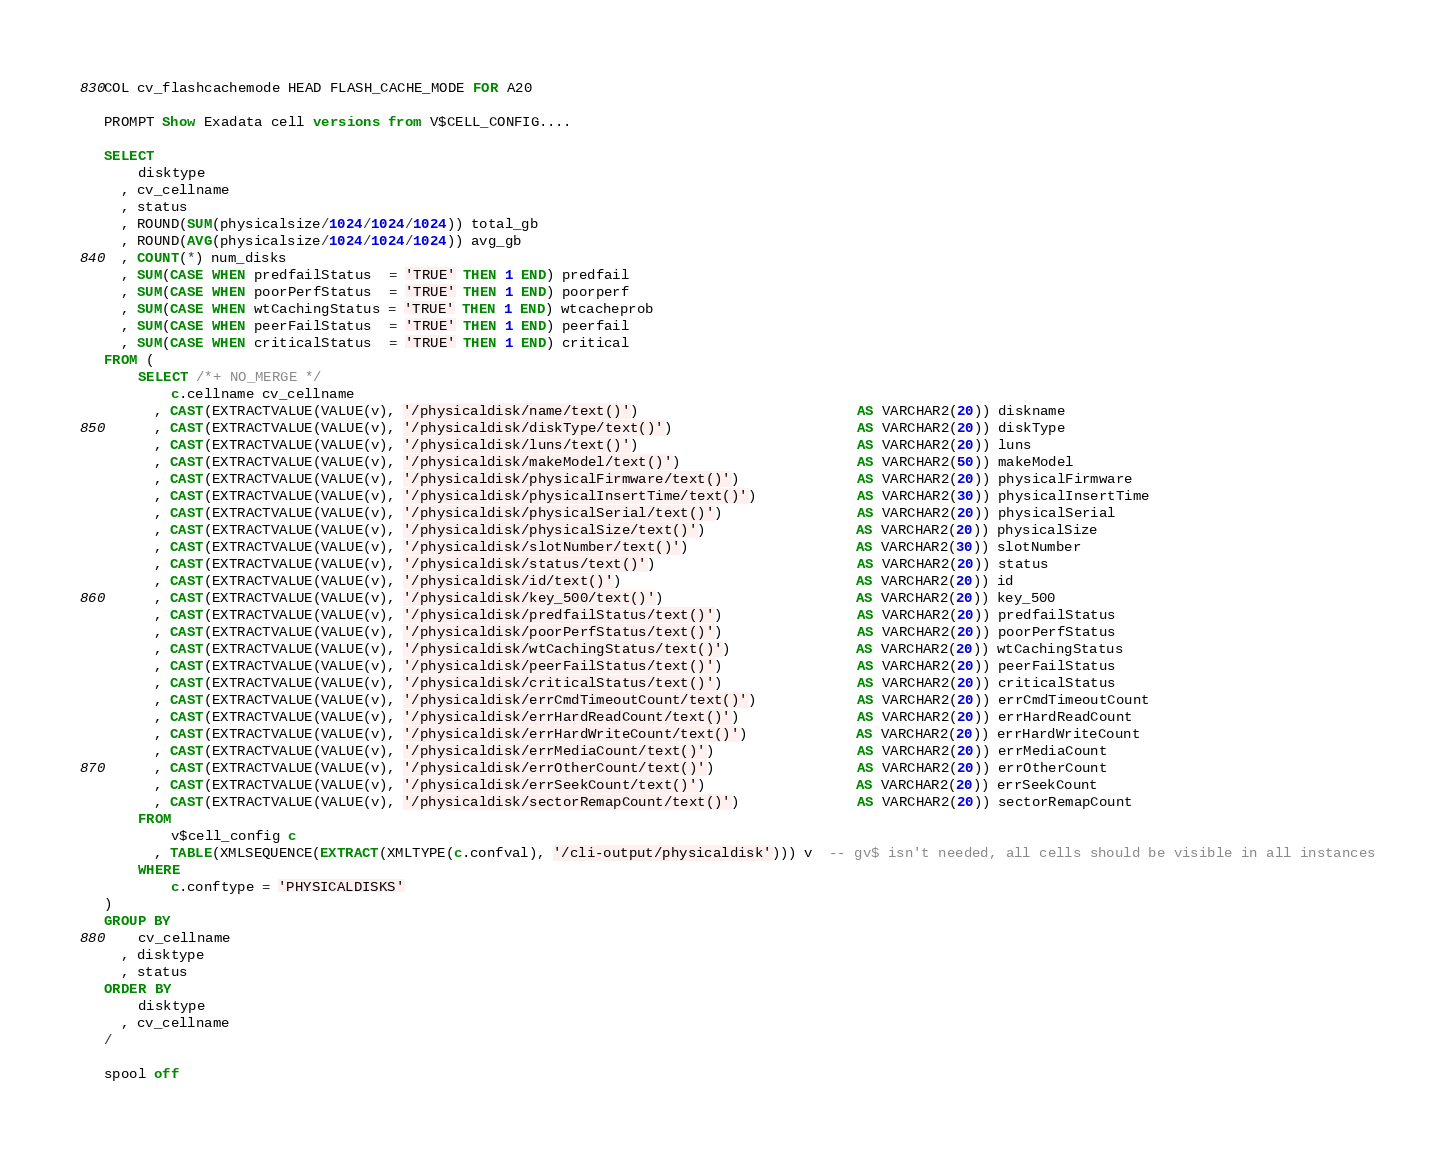<code> <loc_0><loc_0><loc_500><loc_500><_SQL_>COL cv_flashcachemode HEAD FLASH_CACHE_MODE FOR A20

PROMPT Show Exadata cell versions from V$CELL_CONFIG....

SELECT 
    disktype
  , cv_cellname
  , status
  , ROUND(SUM(physicalsize/1024/1024/1024)) total_gb
  , ROUND(AVG(physicalsize/1024/1024/1024)) avg_gb
  , COUNT(*) num_disks
  , SUM(CASE WHEN predfailStatus  = 'TRUE' THEN 1 END) predfail
  , SUM(CASE WHEN poorPerfStatus  = 'TRUE' THEN 1 END) poorperf
  , SUM(CASE WHEN wtCachingStatus = 'TRUE' THEN 1 END) wtcacheprob
  , SUM(CASE WHEN peerFailStatus  = 'TRUE' THEN 1 END) peerfail
  , SUM(CASE WHEN criticalStatus  = 'TRUE' THEN 1 END) critical
FROM (
    SELECT /*+ NO_MERGE */
        c.cellname cv_cellname
      , CAST(EXTRACTVALUE(VALUE(v), '/physicaldisk/name/text()')                          AS VARCHAR2(20)) diskname
      , CAST(EXTRACTVALUE(VALUE(v), '/physicaldisk/diskType/text()')                      AS VARCHAR2(20)) diskType          
      , CAST(EXTRACTVALUE(VALUE(v), '/physicaldisk/luns/text()')                          AS VARCHAR2(20)) luns              
      , CAST(EXTRACTVALUE(VALUE(v), '/physicaldisk/makeModel/text()')                     AS VARCHAR2(50)) makeModel         
      , CAST(EXTRACTVALUE(VALUE(v), '/physicaldisk/physicalFirmware/text()')              AS VARCHAR2(20)) physicalFirmware  
      , CAST(EXTRACTVALUE(VALUE(v), '/physicaldisk/physicalInsertTime/text()')            AS VARCHAR2(30)) physicalInsertTime
      , CAST(EXTRACTVALUE(VALUE(v), '/physicaldisk/physicalSerial/text()')                AS VARCHAR2(20)) physicalSerial    
      , CAST(EXTRACTVALUE(VALUE(v), '/physicaldisk/physicalSize/text()')                  AS VARCHAR2(20)) physicalSize      
      , CAST(EXTRACTVALUE(VALUE(v), '/physicaldisk/slotNumber/text()')                    AS VARCHAR2(30)) slotNumber        
      , CAST(EXTRACTVALUE(VALUE(v), '/physicaldisk/status/text()')                        AS VARCHAR2(20)) status            
      , CAST(EXTRACTVALUE(VALUE(v), '/physicaldisk/id/text()')                            AS VARCHAR2(20)) id                
      , CAST(EXTRACTVALUE(VALUE(v), '/physicaldisk/key_500/text()')                       AS VARCHAR2(20)) key_500           
      , CAST(EXTRACTVALUE(VALUE(v), '/physicaldisk/predfailStatus/text()')                AS VARCHAR2(20)) predfailStatus    
      , CAST(EXTRACTVALUE(VALUE(v), '/physicaldisk/poorPerfStatus/text()')                AS VARCHAR2(20)) poorPerfStatus    
      , CAST(EXTRACTVALUE(VALUE(v), '/physicaldisk/wtCachingStatus/text()')               AS VARCHAR2(20)) wtCachingStatus   
      , CAST(EXTRACTVALUE(VALUE(v), '/physicaldisk/peerFailStatus/text()')                AS VARCHAR2(20)) peerFailStatus    
      , CAST(EXTRACTVALUE(VALUE(v), '/physicaldisk/criticalStatus/text()')                AS VARCHAR2(20)) criticalStatus    
      , CAST(EXTRACTVALUE(VALUE(v), '/physicaldisk/errCmdTimeoutCount/text()')            AS VARCHAR2(20)) errCmdTimeoutCount
      , CAST(EXTRACTVALUE(VALUE(v), '/physicaldisk/errHardReadCount/text()')              AS VARCHAR2(20)) errHardReadCount  
      , CAST(EXTRACTVALUE(VALUE(v), '/physicaldisk/errHardWriteCount/text()')             AS VARCHAR2(20)) errHardWriteCount 
      , CAST(EXTRACTVALUE(VALUE(v), '/physicaldisk/errMediaCount/text()')                 AS VARCHAR2(20)) errMediaCount     
      , CAST(EXTRACTVALUE(VALUE(v), '/physicaldisk/errOtherCount/text()')                 AS VARCHAR2(20)) errOtherCount     
      , CAST(EXTRACTVALUE(VALUE(v), '/physicaldisk/errSeekCount/text()')                  AS VARCHAR2(20)) errSeekCount      
      , CAST(EXTRACTVALUE(VALUE(v), '/physicaldisk/sectorRemapCount/text()')              AS VARCHAR2(20)) sectorRemapCount  
    FROM
        v$cell_config c
      , TABLE(XMLSEQUENCE(EXTRACT(XMLTYPE(c.confval), '/cli-output/physicaldisk'))) v  -- gv$ isn't needed, all cells should be visible in all instances
    WHERE 
        c.conftype = 'PHYSICALDISKS'
)
GROUP BY
    cv_cellname
  , disktype
  , status
ORDER BY
    disktype
  , cv_cellname
/

spool off

</code> 